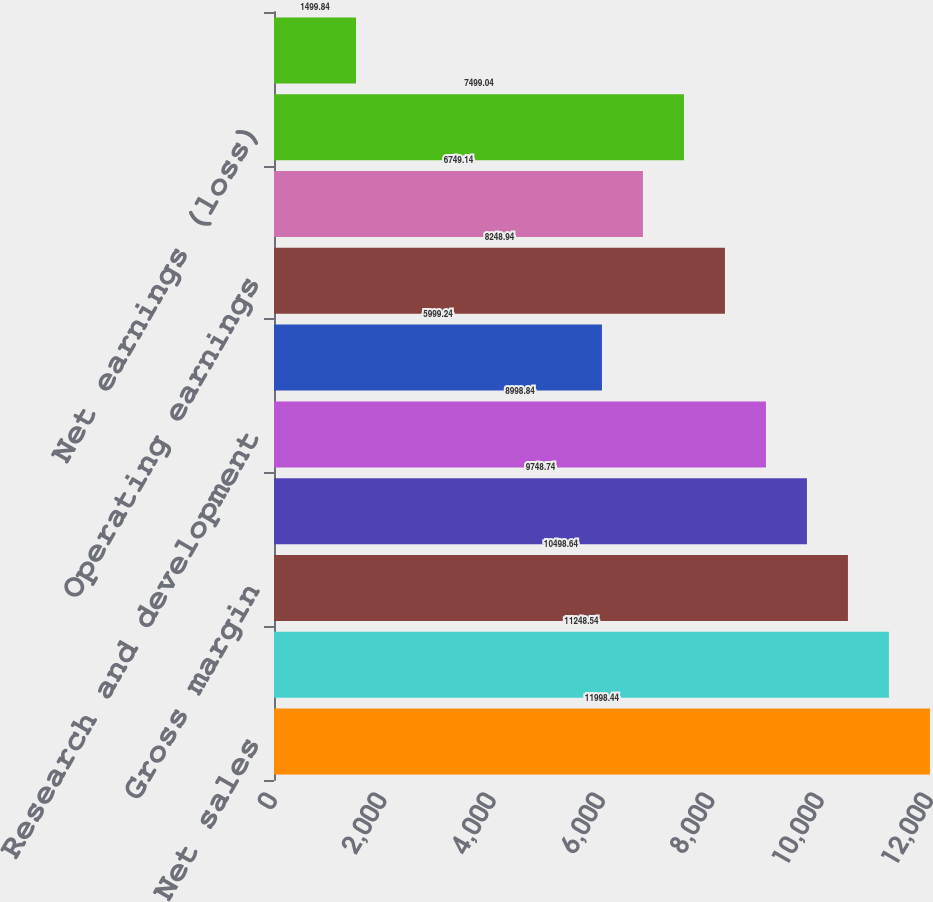<chart> <loc_0><loc_0><loc_500><loc_500><bar_chart><fcel>Net sales<fcel>Costs of sales<fcel>Gross margin<fcel>Selling general and<fcel>Research and development<fcel>Other charges (income)<fcel>Operating earnings<fcel>Earnings from continuing<fcel>Net earnings (loss)<fcel>Basic earnings per common<nl><fcel>11998.4<fcel>11248.5<fcel>10498.6<fcel>9748.74<fcel>8998.84<fcel>5999.24<fcel>8248.94<fcel>6749.14<fcel>7499.04<fcel>1499.84<nl></chart> 